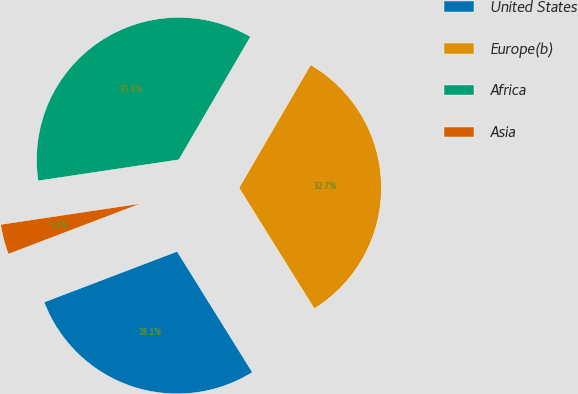Convert chart to OTSL. <chart><loc_0><loc_0><loc_500><loc_500><pie_chart><fcel>United States<fcel>Europe(b)<fcel>Africa<fcel>Asia<nl><fcel>28.07%<fcel>32.75%<fcel>35.76%<fcel>3.43%<nl></chart> 